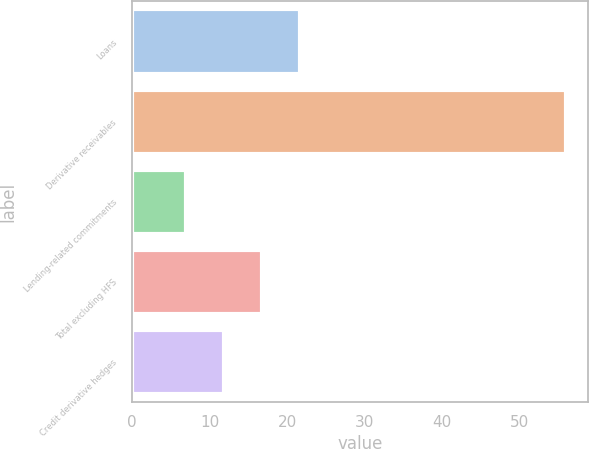<chart> <loc_0><loc_0><loc_500><loc_500><bar_chart><fcel>Loans<fcel>Derivative receivables<fcel>Lending-related commitments<fcel>Total excluding HFS<fcel>Credit derivative hedges<nl><fcel>21.7<fcel>56<fcel>7<fcel>16.8<fcel>11.9<nl></chart> 